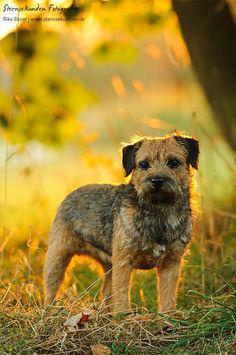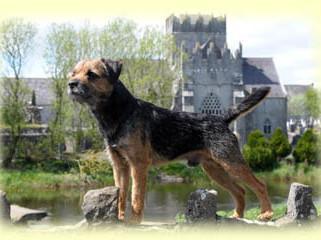The first image is the image on the left, the second image is the image on the right. For the images displayed, is the sentence "The left image shows one dog with a rightward turned body standing on all fours, and the right image shows a dog looking leftward." factually correct? Answer yes or no. Yes. The first image is the image on the left, the second image is the image on the right. For the images shown, is this caption "The left and right image contains the same number of dogs with at least one laying down." true? Answer yes or no. No. 